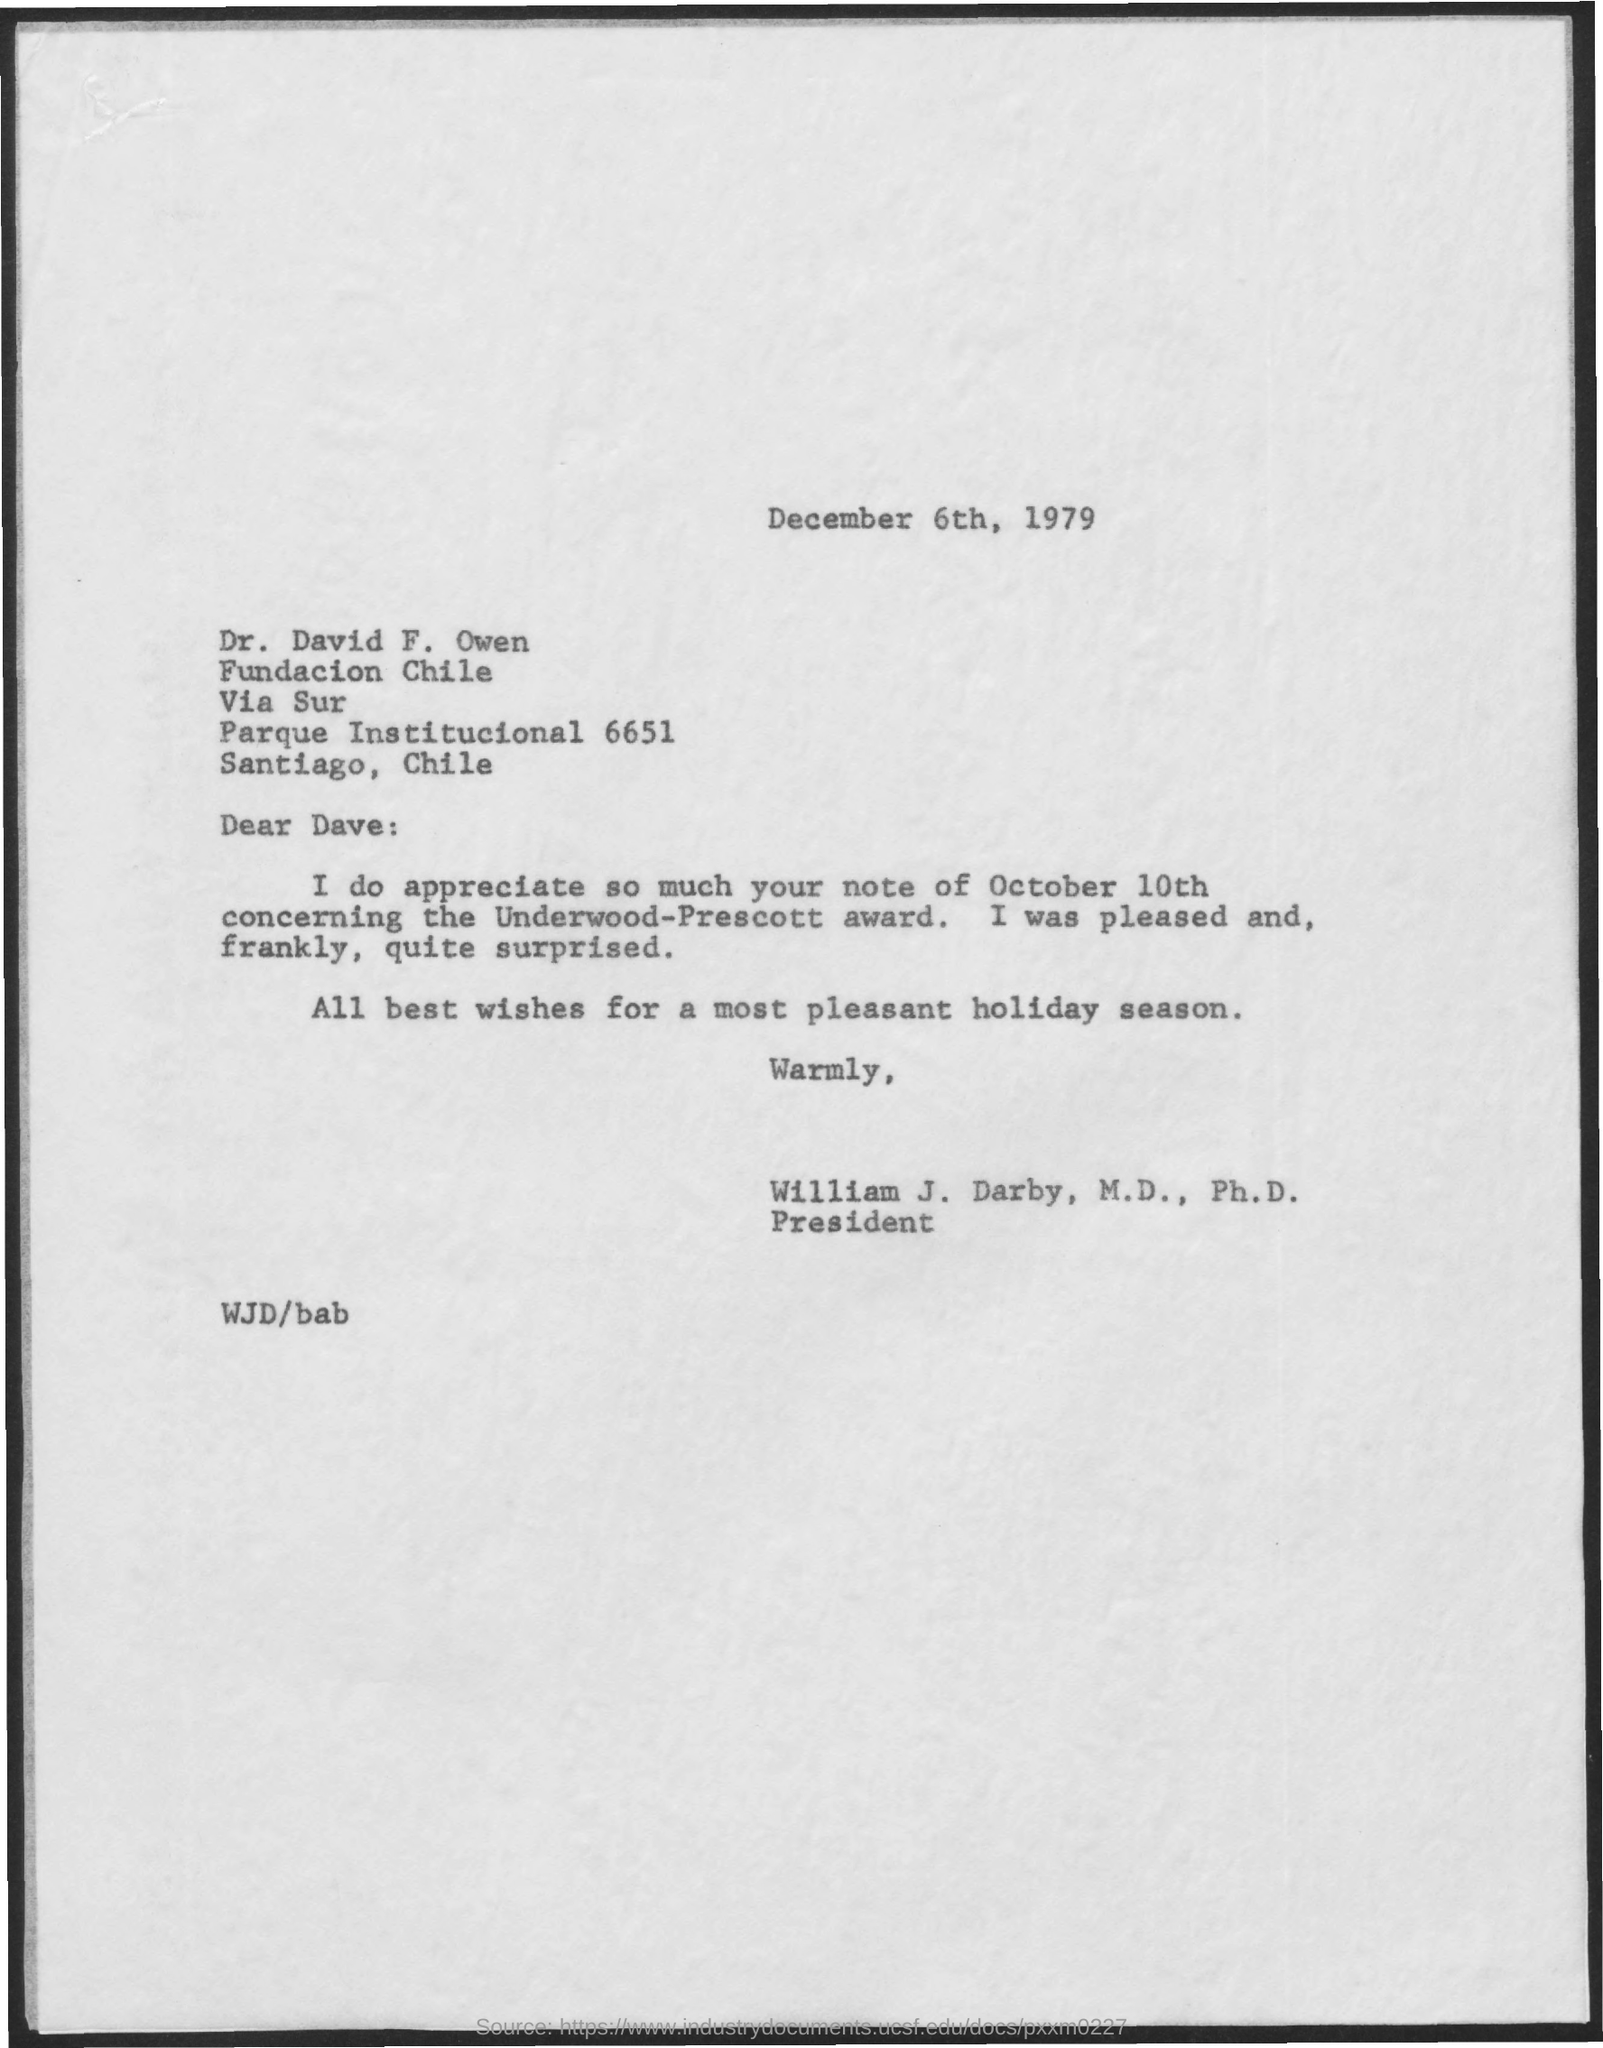What is the date mentioned in the given page ?
Offer a very short reply. December 6th, 1979. What is the designation of william j darby mentioned ?
Ensure brevity in your answer.  PRESIDENT. 